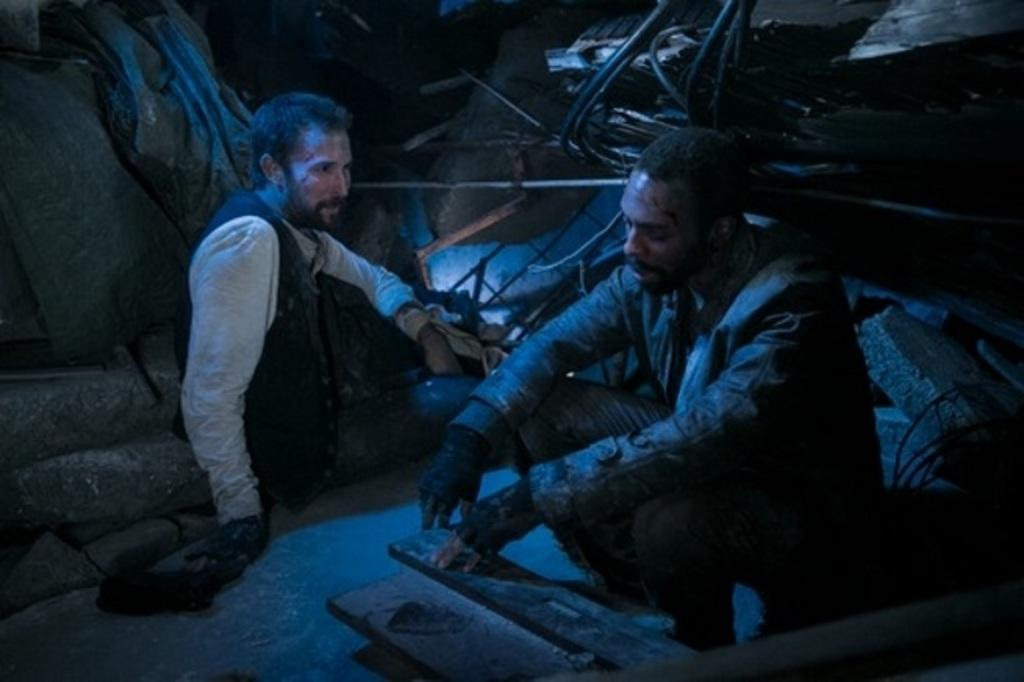How many people are sitting in the image? There are two persons sitting in the image. What type of natural material is present in the image? There are stones and wood in the image. Can you describe any other objects in the image? Yes, there are other objects in the image, but their specific details are not mentioned in the provided facts. What type of flower can be seen growing on the wood in the image? There is no flower growing on the wood in the image. Can you describe the behavior of the squirrel in the image? There is no squirrel present in the image. 